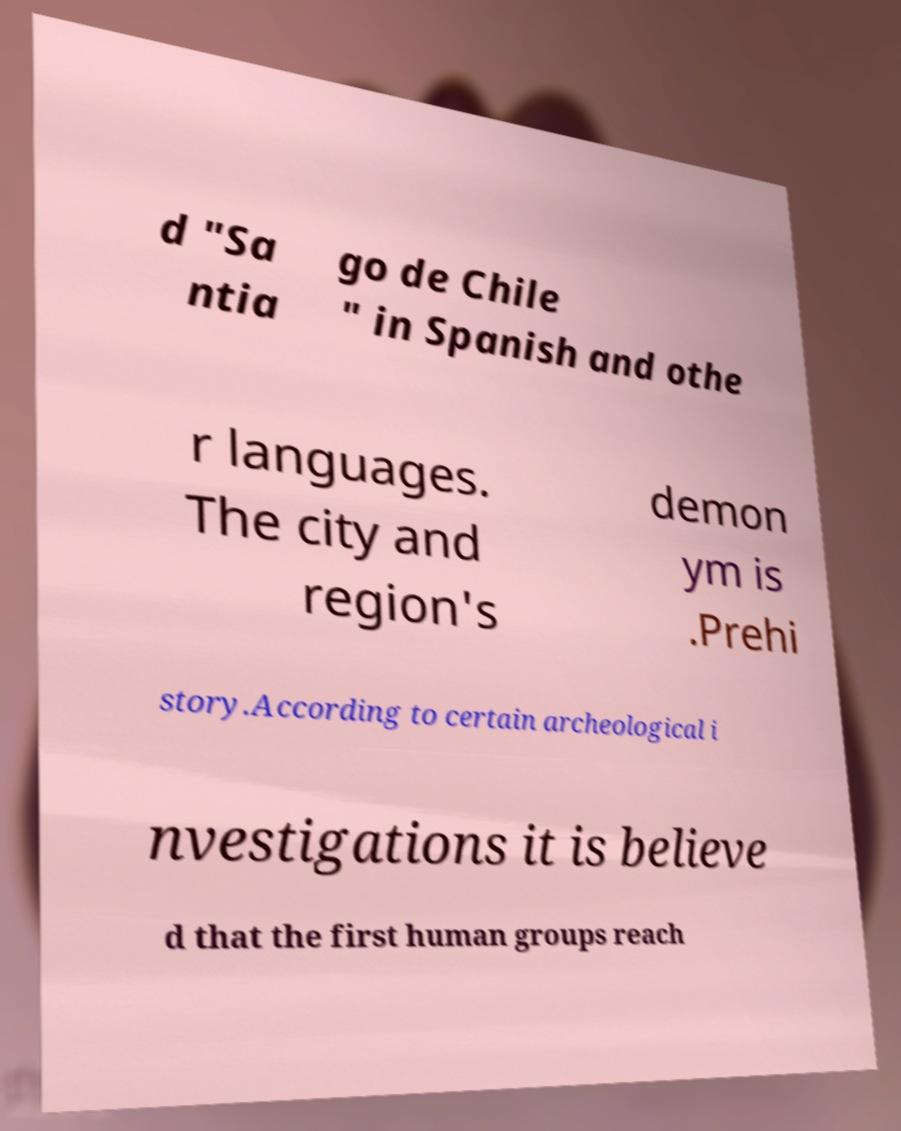Can you accurately transcribe the text from the provided image for me? d "Sa ntia go de Chile " in Spanish and othe r languages. The city and region's demon ym is .Prehi story.According to certain archeological i nvestigations it is believe d that the first human groups reach 